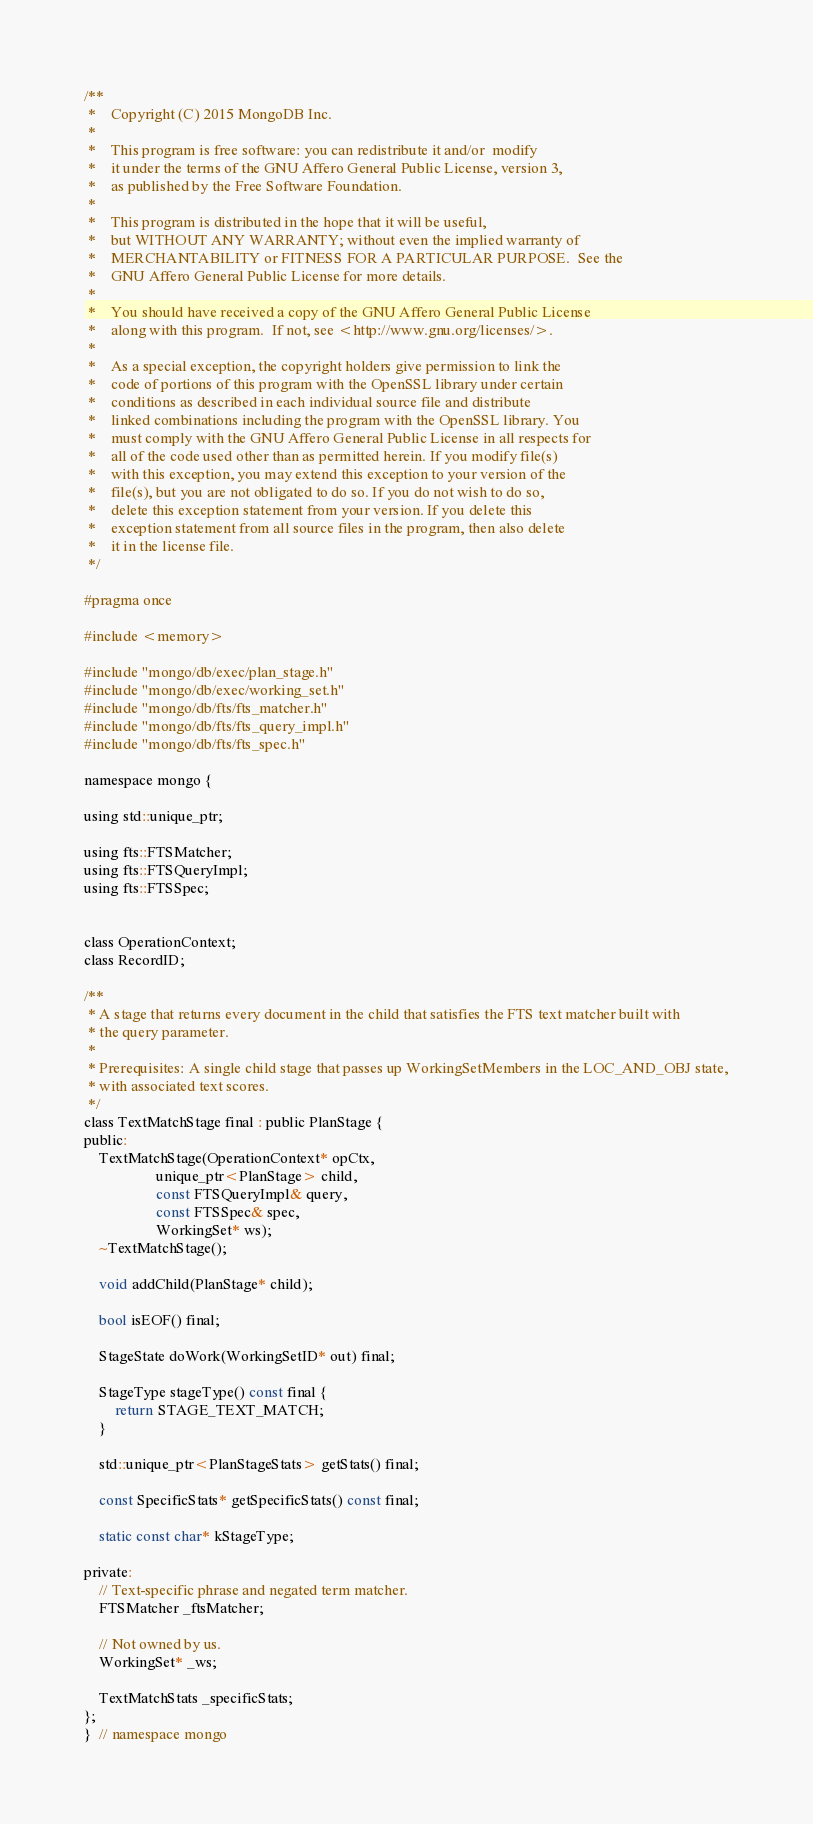Convert code to text. <code><loc_0><loc_0><loc_500><loc_500><_C_>/**
 *    Copyright (C) 2015 MongoDB Inc.
 *
 *    This program is free software: you can redistribute it and/or  modify
 *    it under the terms of the GNU Affero General Public License, version 3,
 *    as published by the Free Software Foundation.
 *
 *    This program is distributed in the hope that it will be useful,
 *    but WITHOUT ANY WARRANTY; without even the implied warranty of
 *    MERCHANTABILITY or FITNESS FOR A PARTICULAR PURPOSE.  See the
 *    GNU Affero General Public License for more details.
 *
 *    You should have received a copy of the GNU Affero General Public License
 *    along with this program.  If not, see <http://www.gnu.org/licenses/>.
 *
 *    As a special exception, the copyright holders give permission to link the
 *    code of portions of this program with the OpenSSL library under certain
 *    conditions as described in each individual source file and distribute
 *    linked combinations including the program with the OpenSSL library. You
 *    must comply with the GNU Affero General Public License in all respects for
 *    all of the code used other than as permitted herein. If you modify file(s)
 *    with this exception, you may extend this exception to your version of the
 *    file(s), but you are not obligated to do so. If you do not wish to do so,
 *    delete this exception statement from your version. If you delete this
 *    exception statement from all source files in the program, then also delete
 *    it in the license file.
 */

#pragma once

#include <memory>

#include "mongo/db/exec/plan_stage.h"
#include "mongo/db/exec/working_set.h"
#include "mongo/db/fts/fts_matcher.h"
#include "mongo/db/fts/fts_query_impl.h"
#include "mongo/db/fts/fts_spec.h"

namespace mongo {

using std::unique_ptr;

using fts::FTSMatcher;
using fts::FTSQueryImpl;
using fts::FTSSpec;


class OperationContext;
class RecordID;

/**
 * A stage that returns every document in the child that satisfies the FTS text matcher built with
 * the query parameter.
 *
 * Prerequisites: A single child stage that passes up WorkingSetMembers in the LOC_AND_OBJ state,
 * with associated text scores.
 */
class TextMatchStage final : public PlanStage {
public:
    TextMatchStage(OperationContext* opCtx,
                   unique_ptr<PlanStage> child,
                   const FTSQueryImpl& query,
                   const FTSSpec& spec,
                   WorkingSet* ws);
    ~TextMatchStage();

    void addChild(PlanStage* child);

    bool isEOF() final;

    StageState doWork(WorkingSetID* out) final;

    StageType stageType() const final {
        return STAGE_TEXT_MATCH;
    }

    std::unique_ptr<PlanStageStats> getStats() final;

    const SpecificStats* getSpecificStats() const final;

    static const char* kStageType;

private:
    // Text-specific phrase and negated term matcher.
    FTSMatcher _ftsMatcher;

    // Not owned by us.
    WorkingSet* _ws;

    TextMatchStats _specificStats;
};
}  // namespace mongo
</code> 